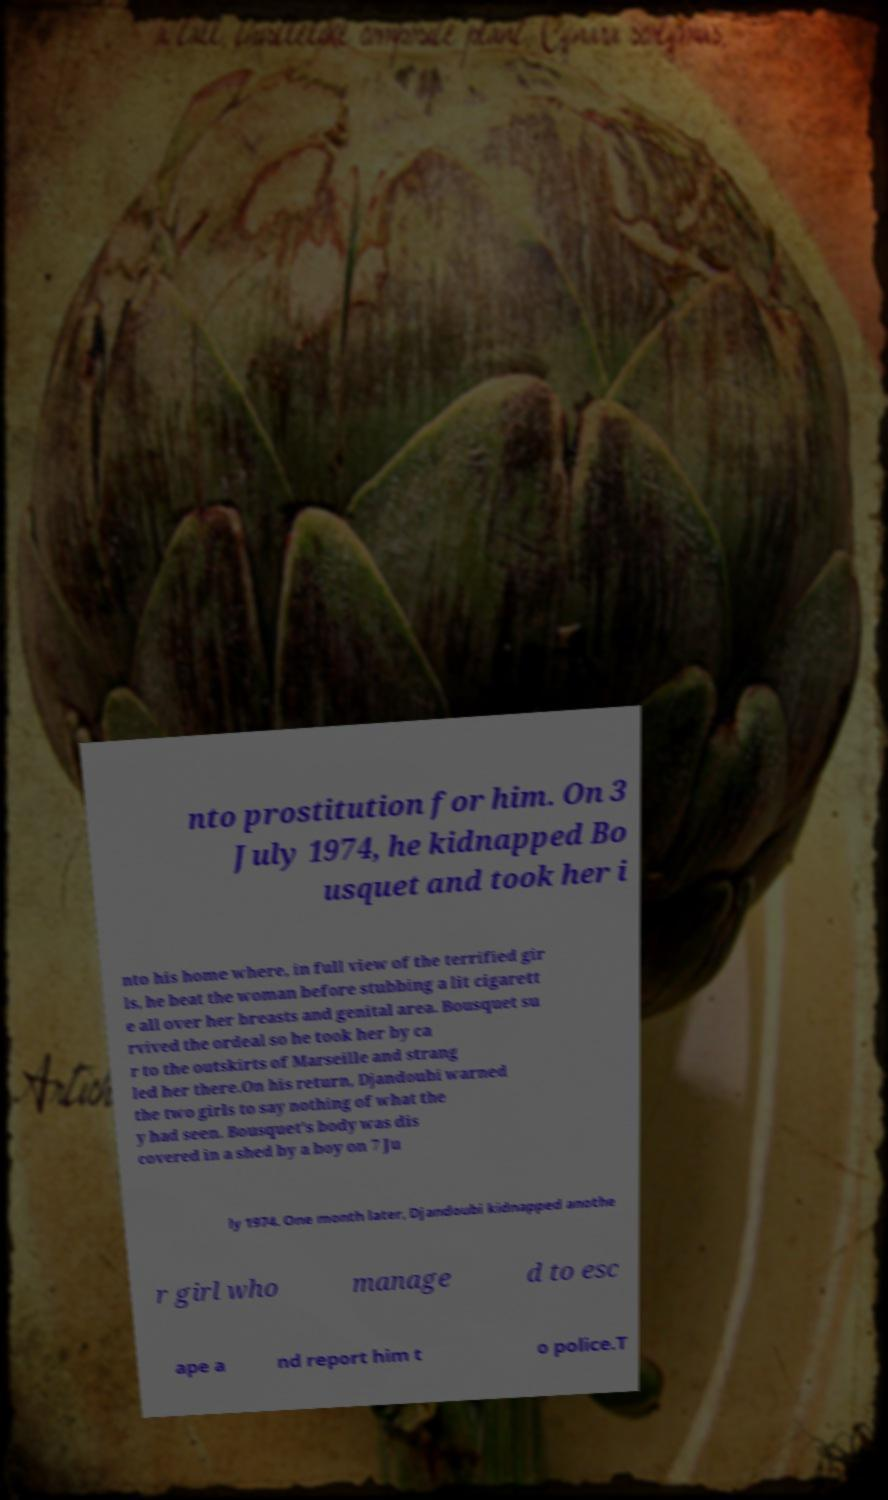Could you assist in decoding the text presented in this image and type it out clearly? nto prostitution for him. On 3 July 1974, he kidnapped Bo usquet and took her i nto his home where, in full view of the terrified gir ls, he beat the woman before stubbing a lit cigarett e all over her breasts and genital area. Bousquet su rvived the ordeal so he took her by ca r to the outskirts of Marseille and strang led her there.On his return, Djandoubi warned the two girls to say nothing of what the y had seen. Bousquet's body was dis covered in a shed by a boy on 7 Ju ly 1974. One month later, Djandoubi kidnapped anothe r girl who manage d to esc ape a nd report him t o police.T 